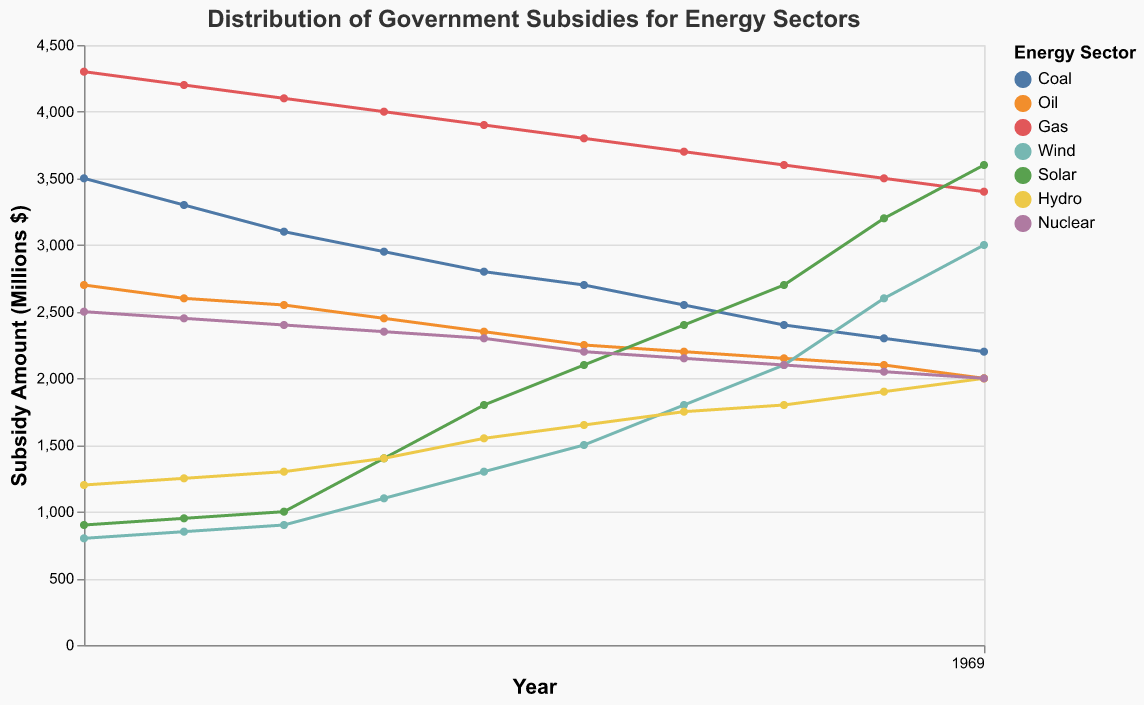What's the title of the figure? The title is displayed at the top of the figure. It reads "Distribution of Government Subsidies for Energy Sectors".
Answer: Distribution of Government Subsidies for Energy Sectors What is the subsidy amount for Solar in the year 2022? Find the Solar data point for the year 2022 on the plot. The Solar subsidy amount is 3600 million dollars.
Answer: 3600 million dollars Which energy sector received the highest subsidy in 2016? Identify the highest point on the graph for the year 2016. Gas received the highest subsidy, which is 4000 million dollars.
Answer: Gas Between which years did Coal subsidies see the most significant decrease? Examine the plot line for Coal and identify the steepest decline between consecutive years. The most substantial decrease happened between 2013 and 2014, dropping from 3500 to 3300 million dollars.
Answer: 2013 and 2014 How much has the subsidy for Wind increased from 2013 to 2022? Find the subsidy amounts for Wind in 2013 and 2022, which are 800 and 3000 million dollars, respectively. The increase is 3000 - 800 = 2200 million dollars.
Answer: 2200 million dollars Which energy sector has the most consistent subsidy amount over the years? Look at the plots for each energy sector and identify the one with the least fluctuation. Nuclear subsidies show the most consistent trend, ranging narrowly around 2500 to 2000 million dollars.
Answer: Nuclear How does the 2014 subsidy amount for Oil compare to Nuclear in the same year? Check the plot for both Oil and Nuclear in 2014. Oil received 2600 million dollars, while Nuclear received 2450 million dollars. Oil's subsidy is higher by 150 million dollars.
Answer: Oil is higher by 150 million dollars What is the average subsidy amount for Solar from 2013 to 2022? Sum the yearly subsidies for Solar from 2013 to 2022 (900 + 950 + 1000 + 1400 + 1800 + 2100 + 2400 + 2700 + 3200 + 3600 = 20050). Divide by the number of years (10). The average is 20050/10 = 2005 million dollars.
Answer: 2005 million dollars In which year did Wind subsidies surpass Nuclear subsidies for the first time? Compare yearly subsidies for Wind and Nuclear. Wind surpassed Nuclear first in 2021, where Wind is 2600 and Nuclear is 2050 million dollars.
Answer: 2021 What is the overall trend in subsidies for Gas from 2013 to 2022? Observe the plot line for Gas from 2013 to 2022. The trend shows a gradual decrease from 4300 million dollars in 2013 to 3400 million dollars in 2022.
Answer: Gradually decreasing 